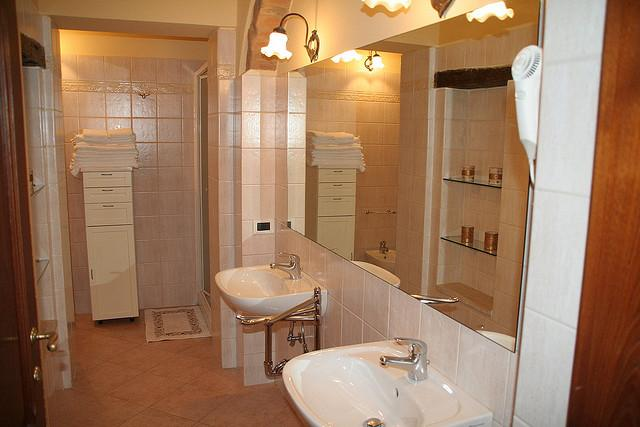What typical bathroom item is integrated into the wall that normally is free standing? Please explain your reasoning. hair dryer. The hair dryer is stuck in the wall. 